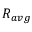<formula> <loc_0><loc_0><loc_500><loc_500>R _ { a v g }</formula> 